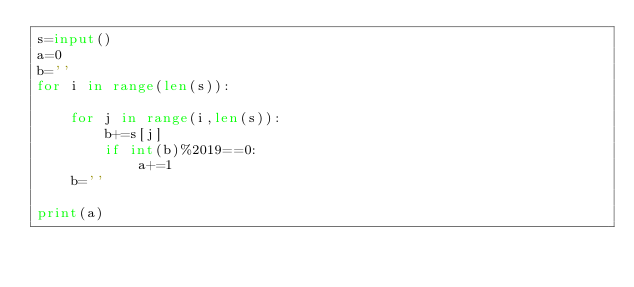<code> <loc_0><loc_0><loc_500><loc_500><_Python_>s=input()
a=0
b=''
for i in range(len(s)):
    
    for j in range(i,len(s)):
        b+=s[j]
        if int(b)%2019==0:
            a+=1
    b=''
        
print(a)</code> 